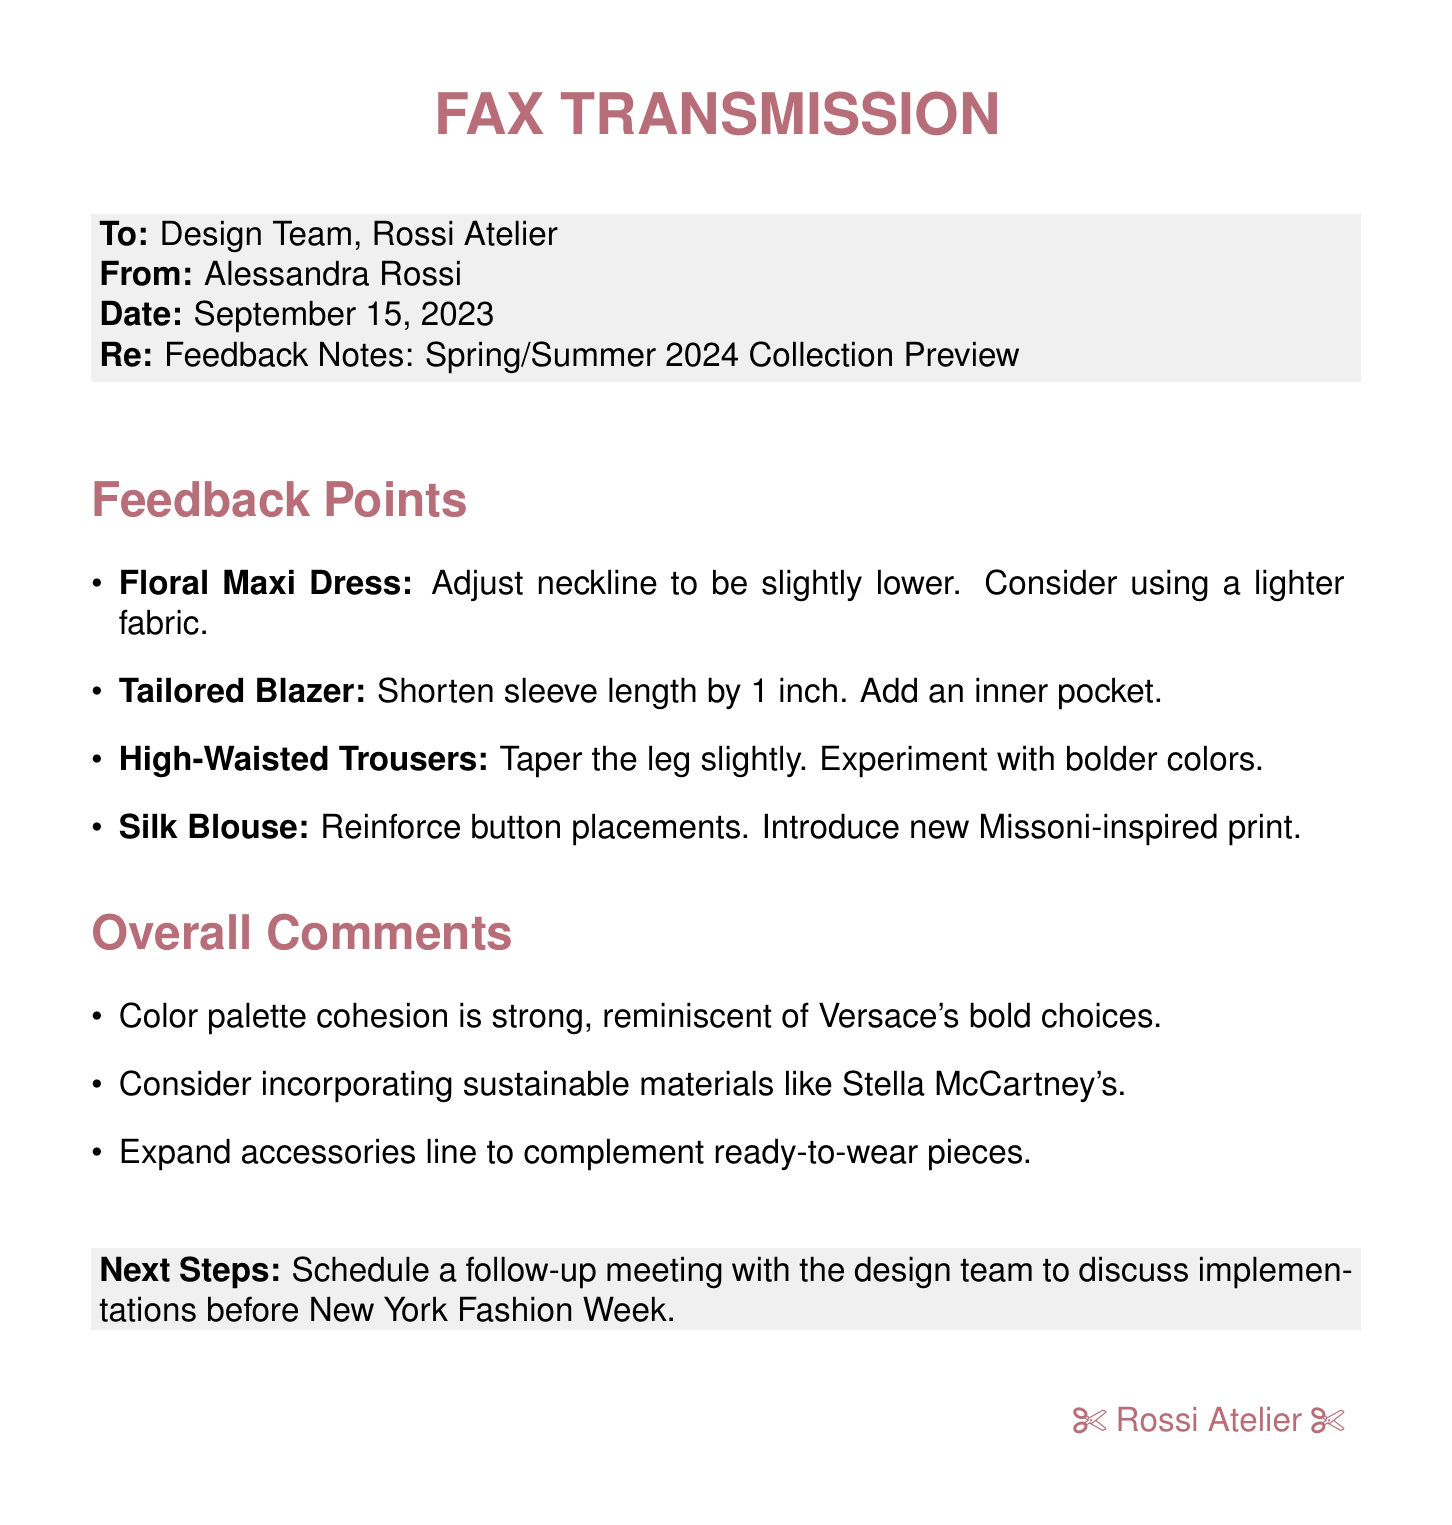What is the date of the feedback notes? The date is stated clearly in the header of the fax.
Answer: September 15, 2023 Who is the sender of the fax? The sender is indicated in the "From" section of the fax document.
Answer: Alessandra Rossi What item requires an adjustment in the neckline? This is mentioned in the feedback points regarding the floral maxi dress.
Answer: Floral Maxi Dress How much should the tailored blazer's sleeve length be shortened? The feedback specifies the exact measurement in inches.
Answer: 1 inch What type of new print is suggested for the silk blouse? The recommendation for the print is directly mentioned in the feedback points.
Answer: Missoni-inspired print What is highlighted as a strong aspect of the collection's overall comments? The overall comments evaluate a specific characteristic of the collection.
Answer: Color palette cohesion What materials are suggested for incorporation in the collection? This suggestion is mentioned in the overall comments.
Answer: Sustainable materials What is the next step to be taken according to this fax? The next step is stated clearly in the last section of the document.
Answer: Schedule a follow-up meeting How does the color palette compare to a well-known brand? The comparison to another brand's choices is mentioned in the overall comments.
Answer: Versace's bold choices 